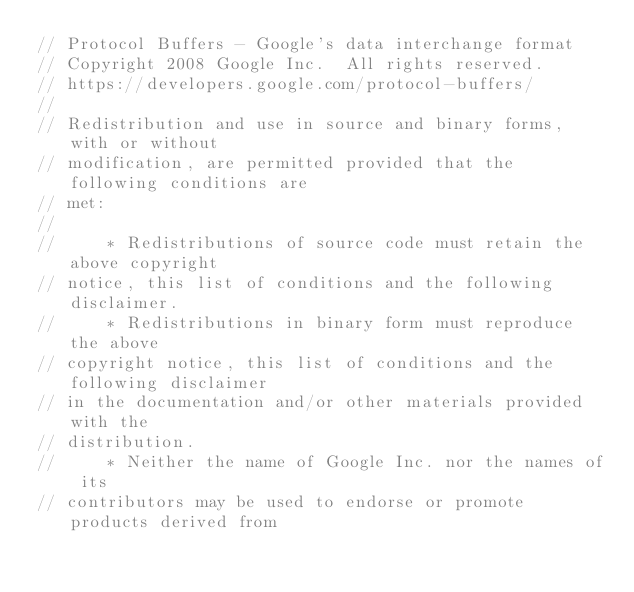<code> <loc_0><loc_0><loc_500><loc_500><_C++_>// Protocol Buffers - Google's data interchange format
// Copyright 2008 Google Inc.  All rights reserved.
// https://developers.google.com/protocol-buffers/
//
// Redistribution and use in source and binary forms, with or without
// modification, are permitted provided that the following conditions are
// met:
//
//     * Redistributions of source code must retain the above copyright
// notice, this list of conditions and the following disclaimer.
//     * Redistributions in binary form must reproduce the above
// copyright notice, this list of conditions and the following disclaimer
// in the documentation and/or other materials provided with the
// distribution.
//     * Neither the name of Google Inc. nor the names of its
// contributors may be used to endorse or promote products derived from</code> 